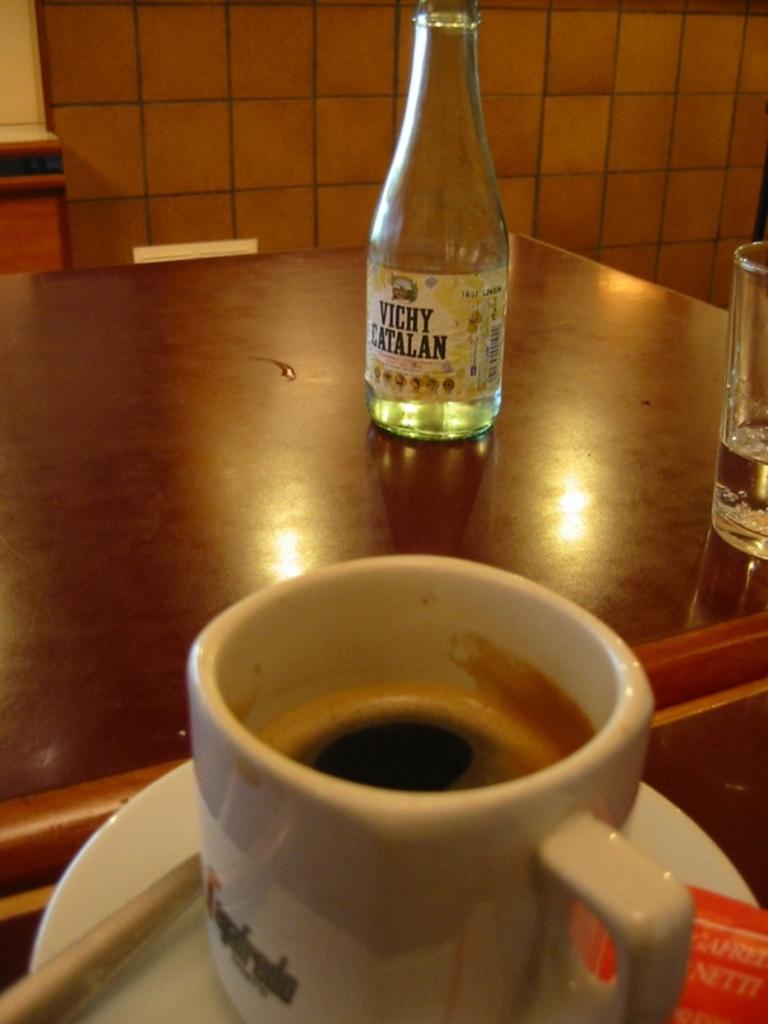What flavor are they?
Offer a very short reply. Unanswerable. 